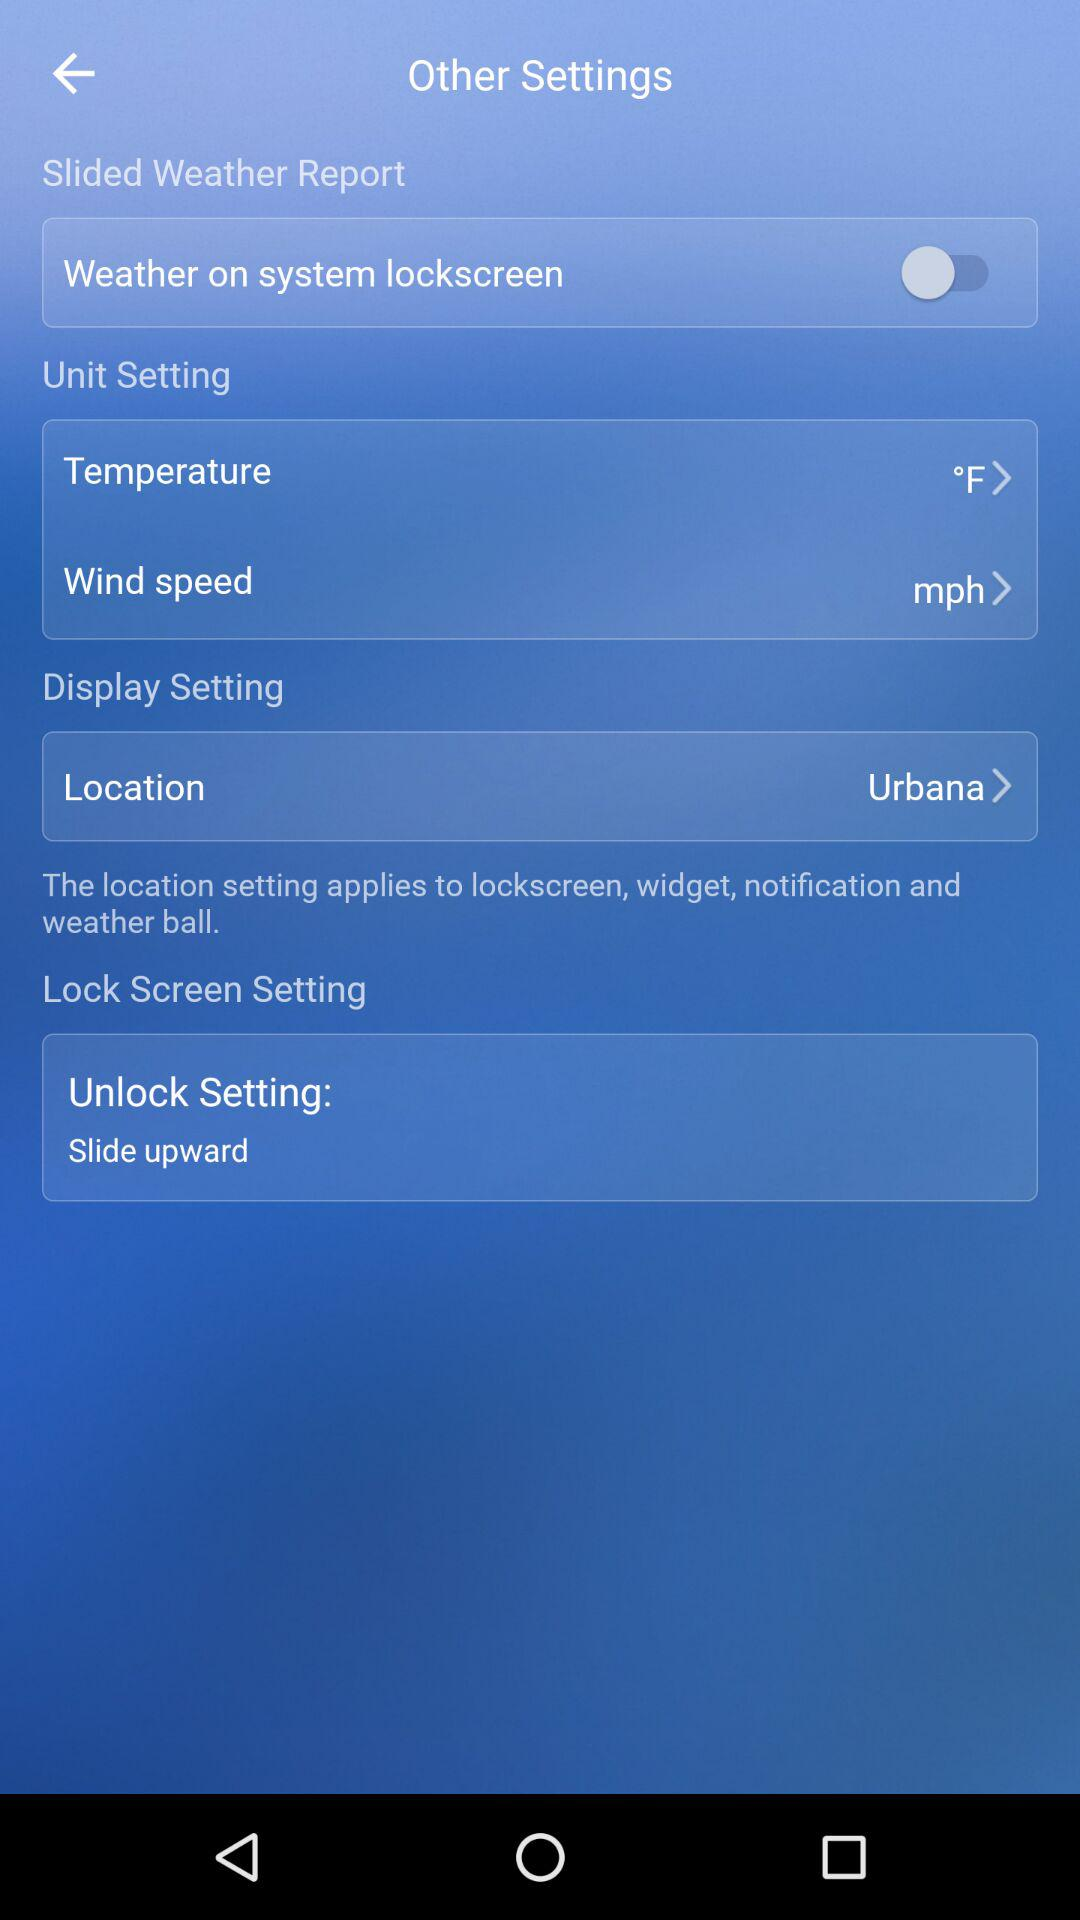What is the selected location? The selected location is Urbana. 